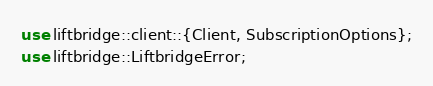Convert code to text. <code><loc_0><loc_0><loc_500><loc_500><_Rust_>use liftbridge::client::{Client, SubscriptionOptions};
use liftbridge::LiftbridgeError;
</code> 